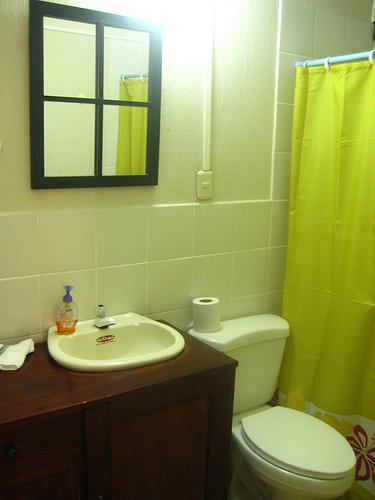Question: what in on the sink?
Choices:
A. Toothbrush.
B. Mouthwash.
C. Handsoap.
D. Toothpaste.
Answer with the letter. Answer: C Question: what color is the shower curtain?
Choices:
A. White.
B. Black.
C. Blue.
D. Yellow.
Answer with the letter. Answer: D Question: why is the seat down?
Choices:
A. The bathroom is closed.
B. The toilet is closed.
C. The toilet is broken.
D. The sink is broken.
Answer with the letter. Answer: B 